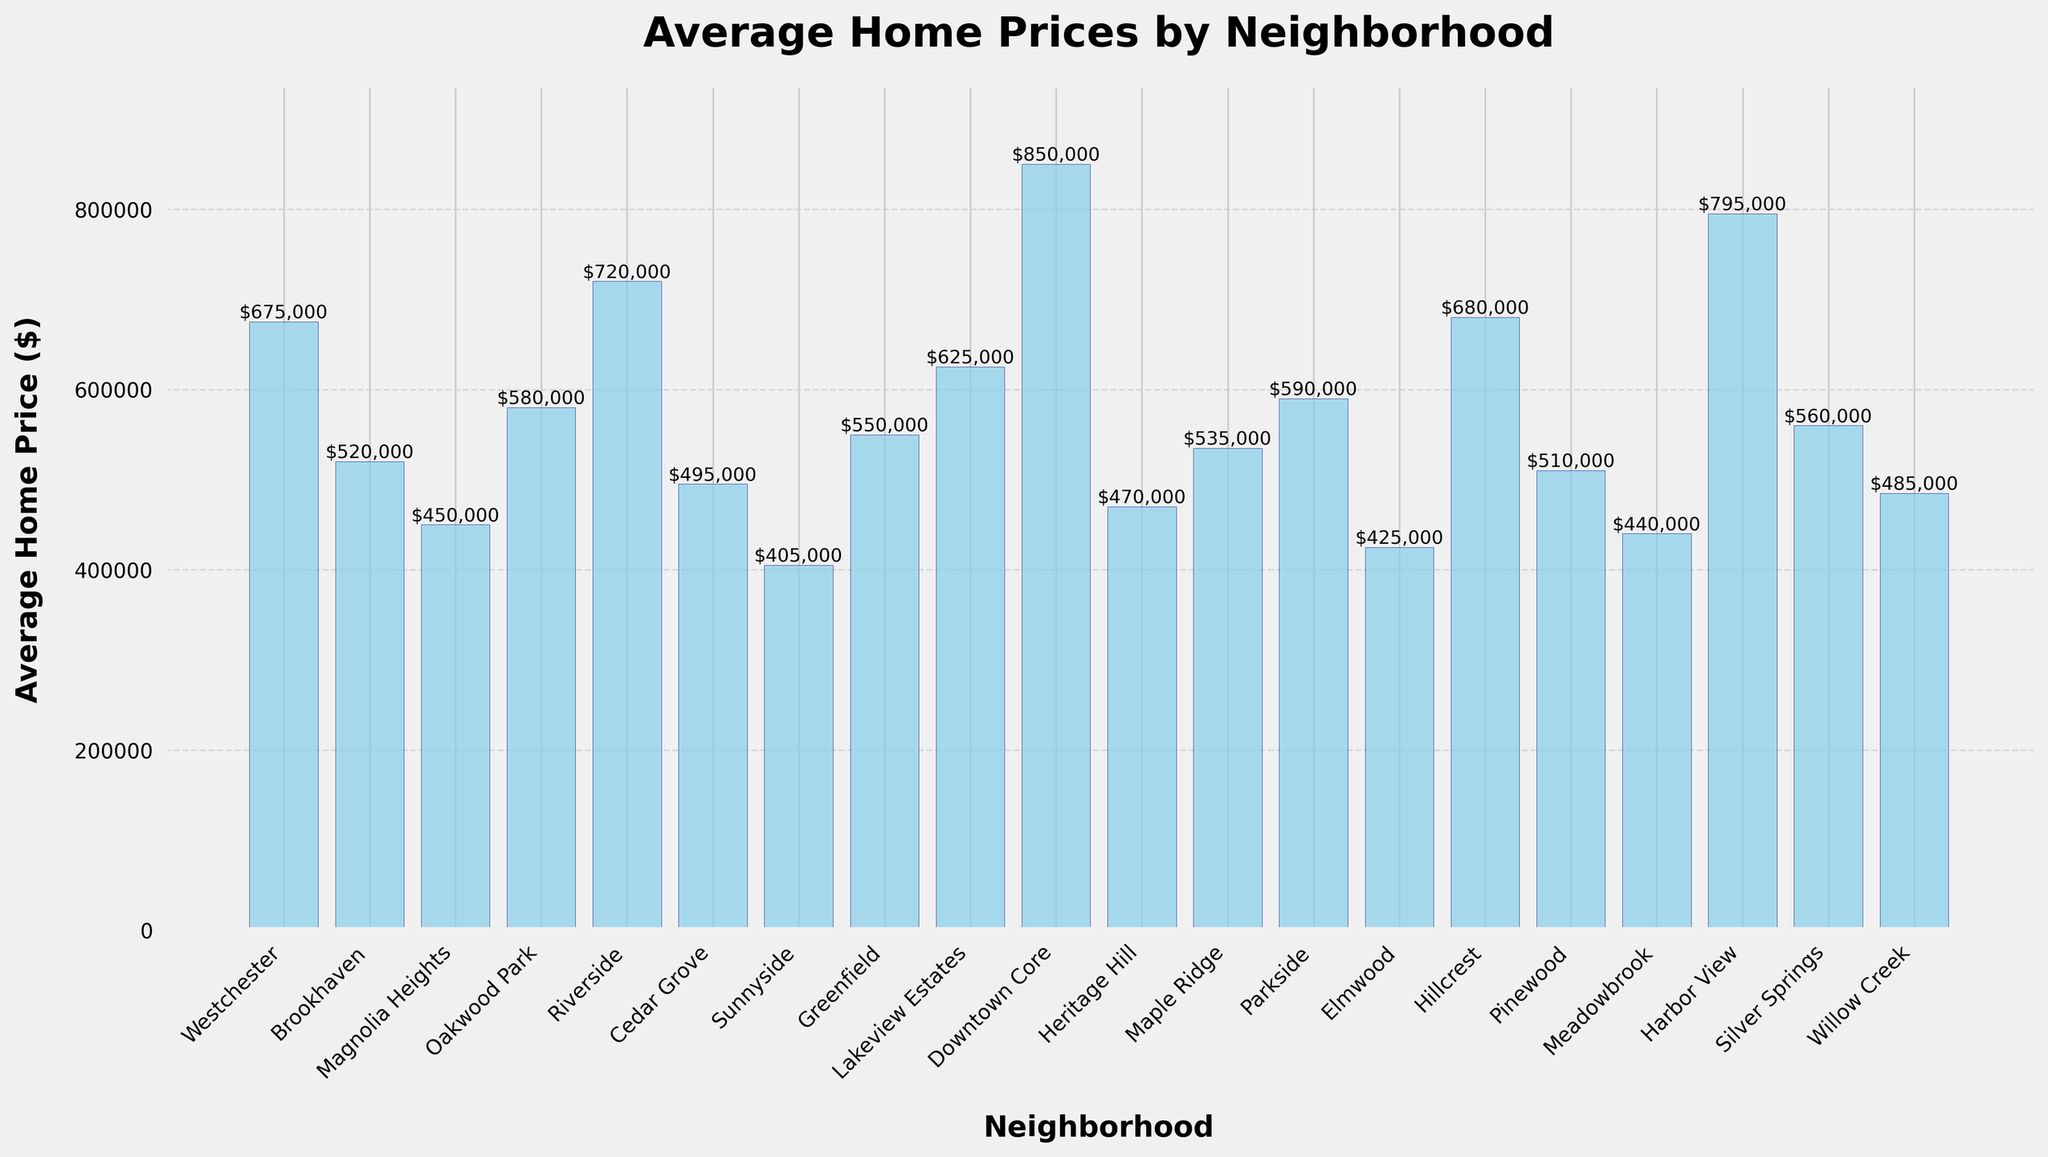What's the highest average home price among the neighborhoods? Identify the bar with the greatest height, which represents the highest average home price. The Downtown Core has the highest bar.
Answer: $850,000 What's the difference in average home price between Oakwood Park and Cedar Grove? Look at the heights of the bars for Oakwood Park and Cedar Grove. Oakwood Park is $580,000 and Cedar Grove is $495,000. The difference is calculated as $580,000 - $495,000.
Answer: $85,000 Which neighborhoods have average home prices greater than $600,000? Identify the bars that have heights above $600,000. The neighborhoods are Westchester, Riverside, Lakeview Estates, Downtown Core, Hillcrest, and Harbor View.
Answer: Westchester, Riverside, Lakeview Estates, Downtown Core, Hillcrest, Harbor View What is the combined average home price for Sunnyside and Elmwood? Find the average home prices for Sunnyside and Elmwood, which are $405,000 and $425,000 respectively. Add them together: $405,000 + $425,000.
Answer: $830,000 Which neighborhood has the lowest average home price? Identify the bar with the smallest height, representing the lowest average home price. Sunnyside has the lowest bar.
Answer: $405,000 Compare the average home prices of Heritage Hill and Silver Springs. Which one is higher and by how much? Look at the bars for Heritage Hill ($470,000) and Silver Springs ($560,000). Silver Springs is higher. Calculate the difference: $560,000 - $470,000.
Answer: Silver Springs by $90,000 What is the median average home price among the neighborhoods? List the prices in ascending order and find the middle value. There are 20 neighborhoods, so the median is the average of the 10th and 11th prices in the ordered list. Once ordered, these prices are $525,000 and $535,000. Calculate the median as ($525,000 + $535,000) / 2.
Answer: $530,000 How many neighborhoods have average home prices below $500,000? Count the bars that represent home prices below $500,000. These neighborhoods are Magnolia Heights, Cedar Grove, Sunnyside, Heritage Hill, Elmwood, Meadowbrook, Willow Creek.
Answer: 7 